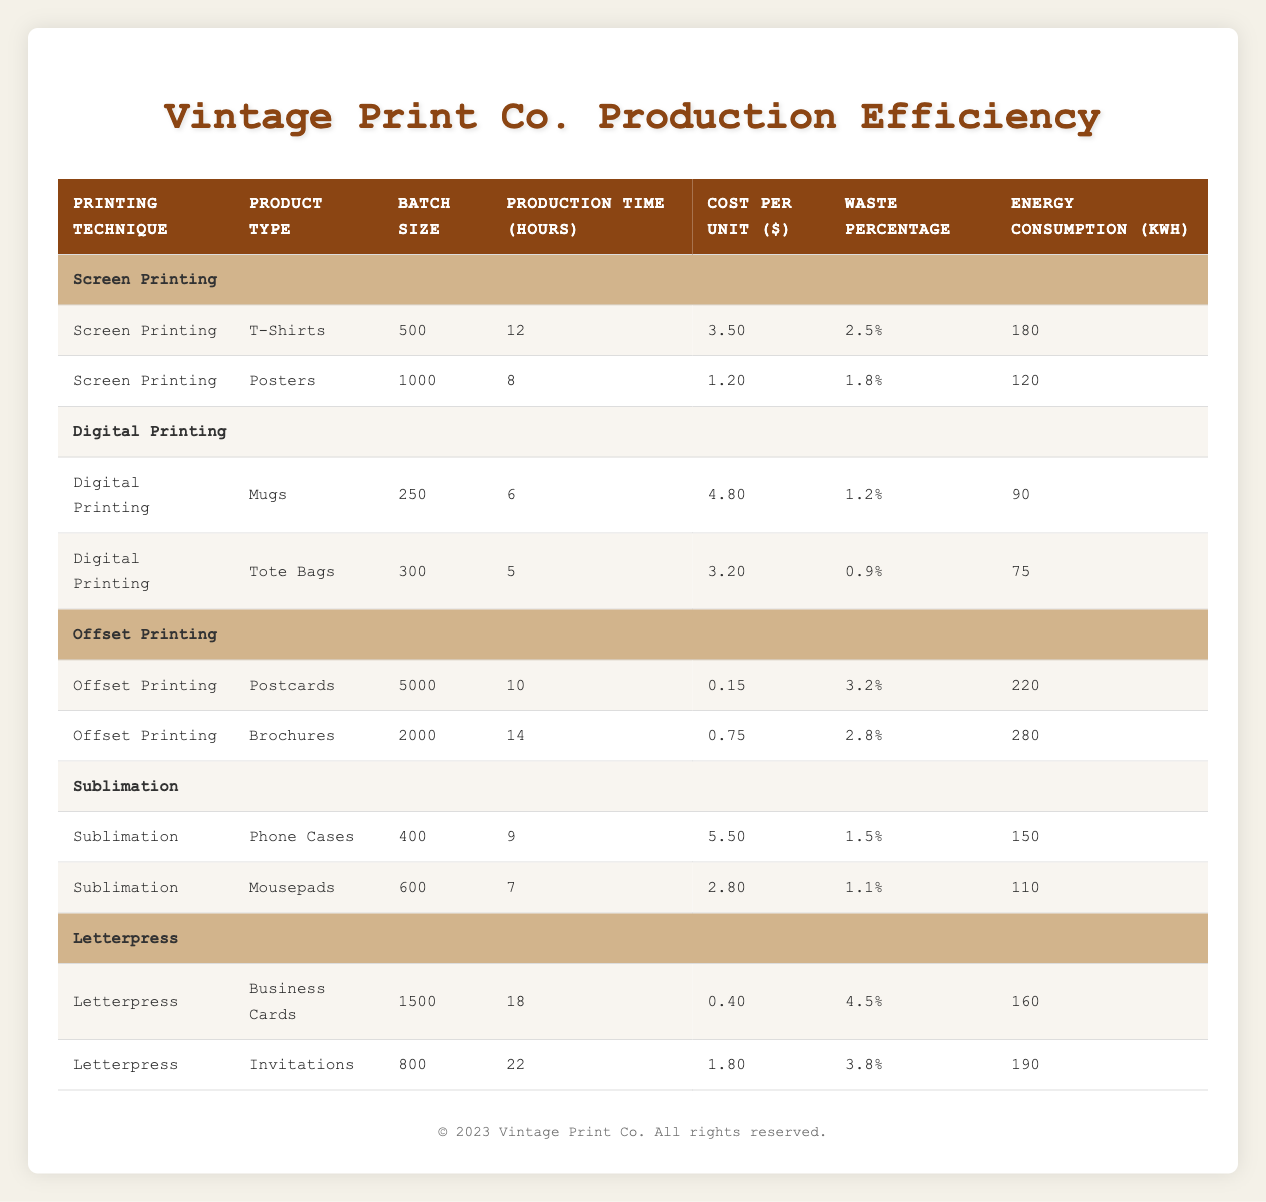What is the cost per unit for T-Shirts using Screen Printing? Looking at the "Cost Per Unit" column under the "Screen Printing" section for T-Shirts, the value is clearly stated as 3.50.
Answer: 3.50 Which printing technique has the highest waste percentage? Across all printing techniques, the "Waste Percentage" shows that Letterpress for Business Cards has the highest value of 4.5.
Answer: 4.5 What is the total production time for all products under Digital Printing? Sum the production times for "Mugs" (6 hours) and "Tote Bags" (5 hours) under Digital Printing: 6 + 5 = 11 hours.
Answer: 11 Is it true that Offset Printing is the most energy-consuming method? Comparing the energy consumption, the highest is 280 kWh from Offset Printing for Brochures, making it true that Offset consumes the most energy in this dataset.
Answer: Yes What is the average cost per unit for Sublimation products? For Sublimation, the costs are 5.50 for Phone Cases and 2.80 for Mousepads. The average is (5.50 + 2.80) / 2 = 4.15.
Answer: 4.15 How many products have a batch size of 1000 or more? The products with batch sizes are: Postcards (5000), Brochures (2000), and Posters (1000), which sums up to three products meeting this criterion.
Answer: 3 Which printing technique requires the least production time for a single product? Examining the production times, "Tote Bags" under Digital Printing requires only 5 hours, the least among the products listed.
Answer: 5 How much energy does Screen Printing consume in total? The energy consumption values for Screen Printing are 180 kWh for T-Shirts and 120 kWh for Posters. Adding these gives 180 + 120 = 300 kWh total.
Answer: 300 What percentage of waste is associated with Offset Printing for Brochures? In the table, the waste percentage listed for Brochures under Offset Printing is 2.8%.
Answer: 2.8 